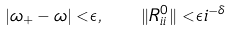<formula> <loc_0><loc_0><loc_500><loc_500>| \omega _ { + } - \omega | < \epsilon , \quad \| R ^ { 0 } _ { i i } \| < \epsilon i ^ { - \delta }</formula> 